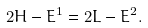Convert formula to latex. <formula><loc_0><loc_0><loc_500><loc_500>2 H - E ^ { 1 } = 2 L - { E } ^ { 2 } .</formula> 